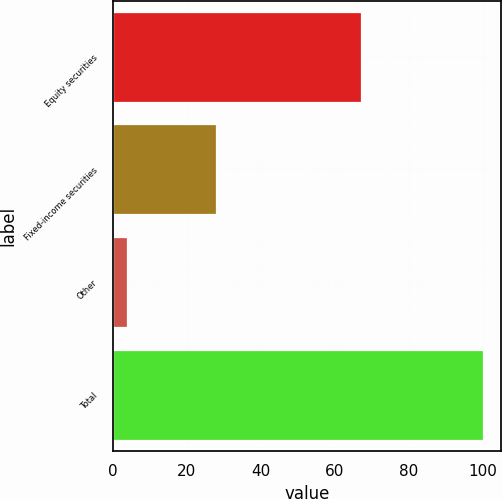Convert chart to OTSL. <chart><loc_0><loc_0><loc_500><loc_500><bar_chart><fcel>Equity securities<fcel>Fixed-income securities<fcel>Other<fcel>Total<nl><fcel>67<fcel>28<fcel>4<fcel>100<nl></chart> 